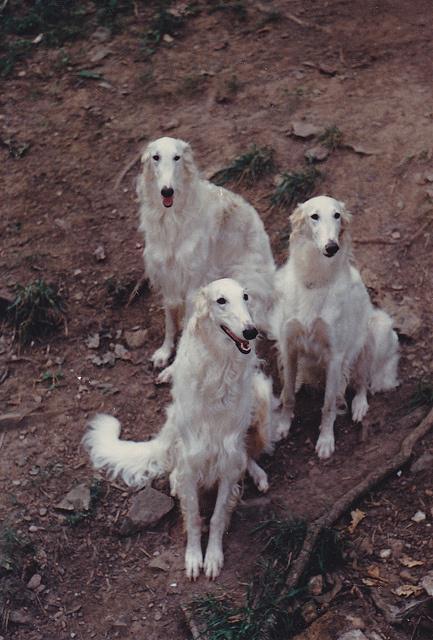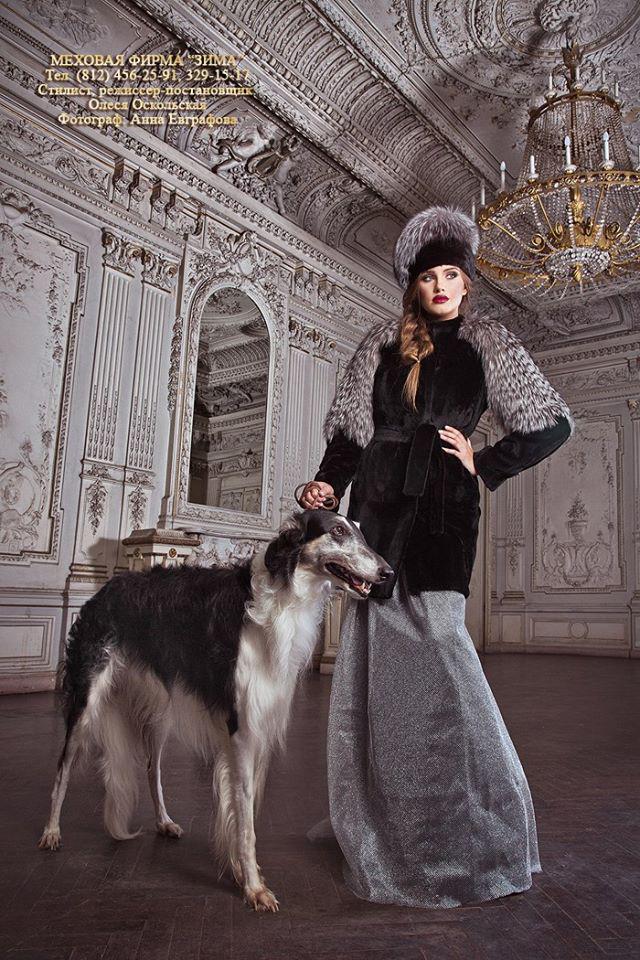The first image is the image on the left, the second image is the image on the right. Analyze the images presented: Is the assertion "One image shows at least one large dog with a handler at a majestic building, while the other image of at least two dogs is set in a rustic outdoor area." valid? Answer yes or no. Yes. The first image is the image on the left, the second image is the image on the right. Evaluate the accuracy of this statement regarding the images: "An image shows a human hand next to the head of a hound posed in front of ornate architecture.". Is it true? Answer yes or no. Yes. 